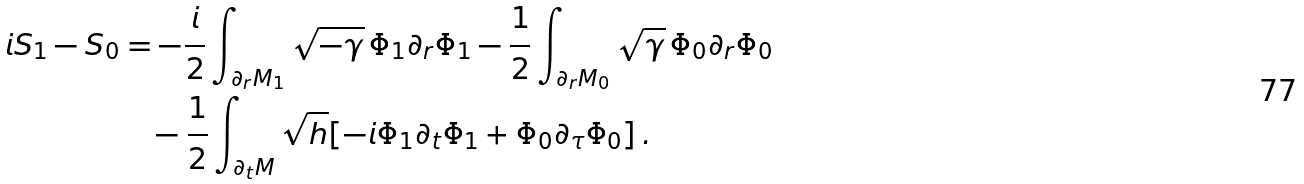Convert formula to latex. <formula><loc_0><loc_0><loc_500><loc_500>i S _ { 1 } - S _ { 0 } & = - \frac { i } { 2 } \int _ { \partial _ { r } M _ { 1 } } \sqrt { - \gamma } \, \Phi _ { 1 } \partial _ { r } \Phi _ { 1 } - \frac { 1 } { 2 } \int _ { \partial _ { r } M _ { 0 } } \sqrt { \gamma } \, \Phi _ { 0 } \partial _ { r } \Phi _ { 0 } \\ & \quad - \frac { 1 } { 2 } \int _ { \partial _ { t } M } \sqrt { h } [ - i \Phi _ { 1 } \partial _ { t } \Phi _ { 1 } + \Phi _ { 0 } \partial _ { \tau } \Phi _ { 0 } ] \, . \\</formula> 